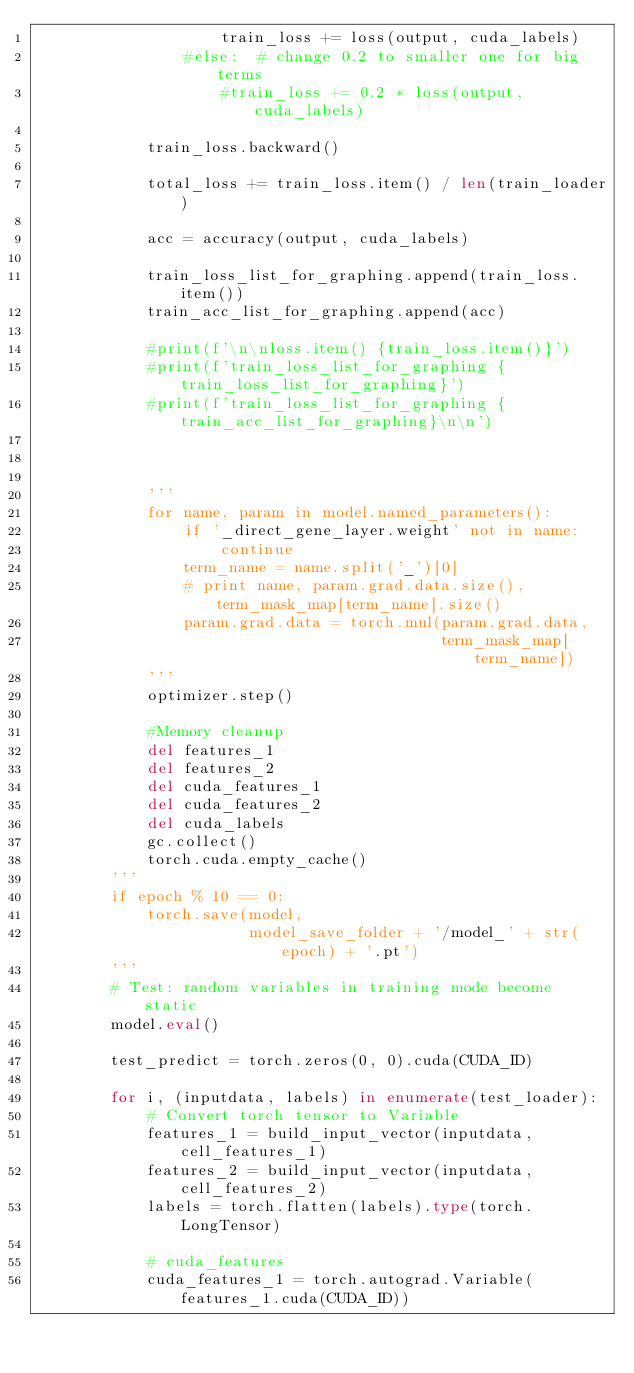Convert code to text. <code><loc_0><loc_0><loc_500><loc_500><_Python_>                    train_loss += loss(output, cuda_labels)
                #else:  # change 0.2 to smaller one for big terms
                    #train_loss += 0.2 * loss(output, cuda_labels)

            train_loss.backward()

            total_loss += train_loss.item() / len(train_loader)
    
            acc = accuracy(output, cuda_labels)
            
            train_loss_list_for_graphing.append(train_loss.item())
            train_acc_list_for_graphing.append(acc)
            
            #print(f'\n\nloss.item() {train_loss.item()}')
            #print(f'train_loss_list_for_graphing {train_loss_list_for_graphing}')
            #print(f'train_loss_list_for_graphing {train_acc_list_for_graphing}\n\n')
            


            '''
            for name, param in model.named_parameters():
                if '_direct_gene_layer.weight' not in name:
                    continue
                term_name = name.split('_')[0]
                # print name, param.grad.data.size(), term_mask_map[term_name].size()
                param.grad.data = torch.mul(param.grad.data,
                                            term_mask_map[term_name])
            '''
            optimizer.step()
            
            #Memory cleanup
            del features_1
            del features_2
            del cuda_features_1
            del cuda_features_2
            del cuda_labels
            gc.collect()
            torch.cuda.empty_cache()
        '''
        if epoch % 10 == 0:
            torch.save(model,
                       model_save_folder + '/model_' + str(epoch) + '.pt')
        '''
        # Test: random variables in training mode become static
        model.eval()

        test_predict = torch.zeros(0, 0).cuda(CUDA_ID)

        for i, (inputdata, labels) in enumerate(test_loader):
            # Convert torch tensor to Variable
            features_1 = build_input_vector(inputdata, cell_features_1)
            features_2 = build_input_vector(inputdata, cell_features_2)
            labels = torch.flatten(labels).type(torch.LongTensor)

            # cuda_features 
            cuda_features_1 = torch.autograd.Variable(features_1.cuda(CUDA_ID))</code> 